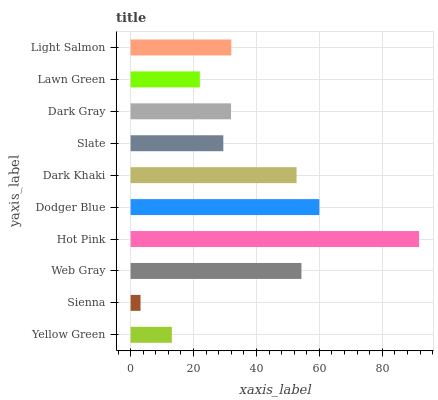Is Sienna the minimum?
Answer yes or no. Yes. Is Hot Pink the maximum?
Answer yes or no. Yes. Is Web Gray the minimum?
Answer yes or no. No. Is Web Gray the maximum?
Answer yes or no. No. Is Web Gray greater than Sienna?
Answer yes or no. Yes. Is Sienna less than Web Gray?
Answer yes or no. Yes. Is Sienna greater than Web Gray?
Answer yes or no. No. Is Web Gray less than Sienna?
Answer yes or no. No. Is Light Salmon the high median?
Answer yes or no. Yes. Is Dark Gray the low median?
Answer yes or no. Yes. Is Sienna the high median?
Answer yes or no. No. Is Web Gray the low median?
Answer yes or no. No. 